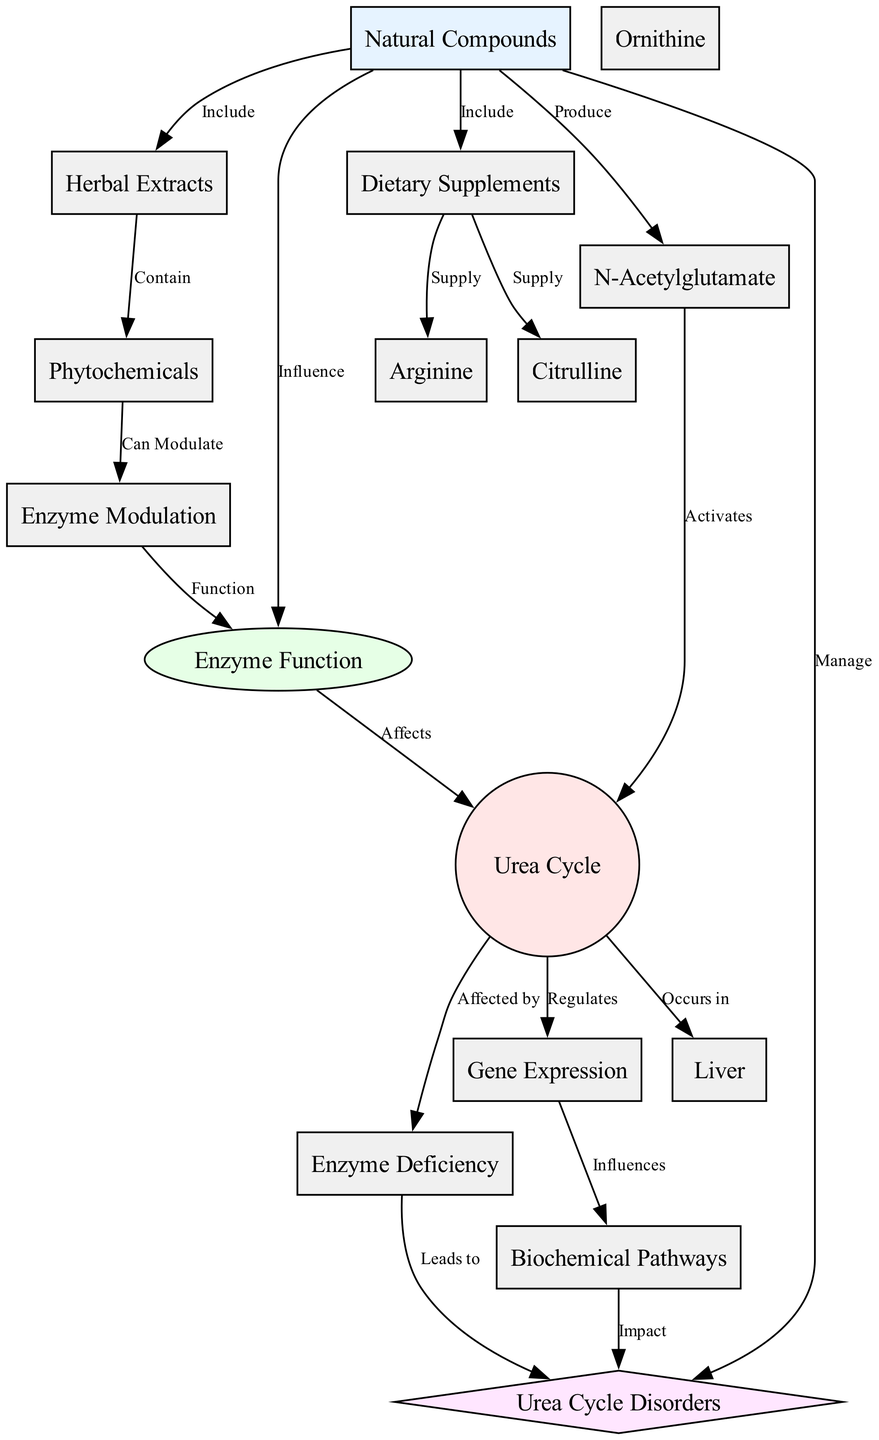What is the main function of Natural Compounds in relation to Urea Cycle Disorders? The diagram indicates that Natural Compounds "Manage" Urea Cycle Disorders, showing a direct relationship where they play a key role in influencing the management of these disorders.
Answer: Manage Which organ is primarily associated with the Urea Cycle? The diagram explicitly states that the Urea Cycle "Occurs in" the Liver, linking these two nodes directly.
Answer: Liver How many different types of Natural Compounds are included in the diagram? The diagram presents three specific types of Natural Compounds: Dietary Supplements, Herbal Extracts, and N-Acetylglutamate, thus totaling three distinct groups.
Answer: Three What does N-Acetylglutamate do to the Urea Cycle? According to the diagram, N-Acetylglutamate "Activates" the Urea Cycle, which indicates its role in enhancing cyclic activity.
Answer: Activates Which node is influenced by Gene Expression? The diagram shows that Gene Expression "Influences" Biochemical Pathways, establishing a clear flow of information from one to the other.
Answer: Biochemical Pathways How do Phytochemicals affect Enzyme Function? The diagram states that Phytochemicals "Can Modulate" Enzyme Function, which demonstrates their capacity to affect how enzymes work within the cycle.
Answer: Can Modulate What is the relationship between Enzyme Deficiency and Urea Cycle Disorders? The diagram indicates that Enzyme Deficiency "Leads to" Urea Cycle Disorders, showing a direct cause-and-effect relationship between these two concepts.
Answer: Leads to Which compounds are supplied as Dietary Supplements? The diagram identifies two specific compounds supplied as Dietary Supplements: Arginine and Citrulline, thus highlighting their relevance in this context.
Answer: Arginine and Citrulline How do Natural Compounds influence Enzyme Function? The diagram indicates that Natural Compounds "Influence" Enzyme Function, meaning they play a part in regulating how these enzymes operate.
Answer: Influence 